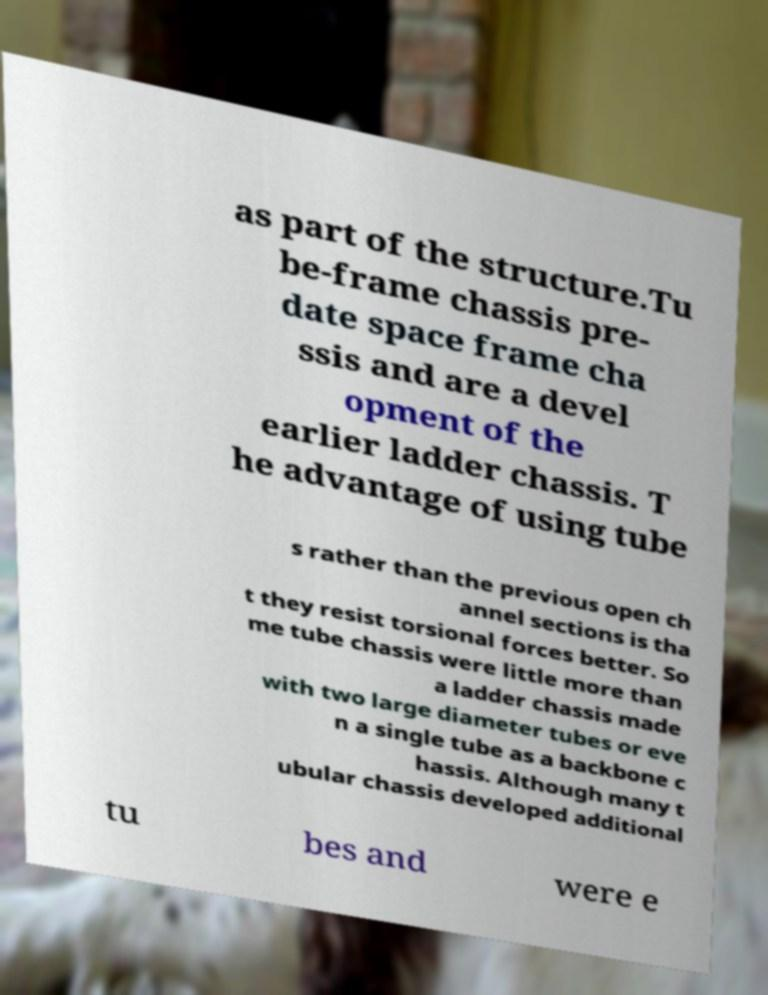Can you read and provide the text displayed in the image?This photo seems to have some interesting text. Can you extract and type it out for me? as part of the structure.Tu be-frame chassis pre- date space frame cha ssis and are a devel opment of the earlier ladder chassis. T he advantage of using tube s rather than the previous open ch annel sections is tha t they resist torsional forces better. So me tube chassis were little more than a ladder chassis made with two large diameter tubes or eve n a single tube as a backbone c hassis. Although many t ubular chassis developed additional tu bes and were e 